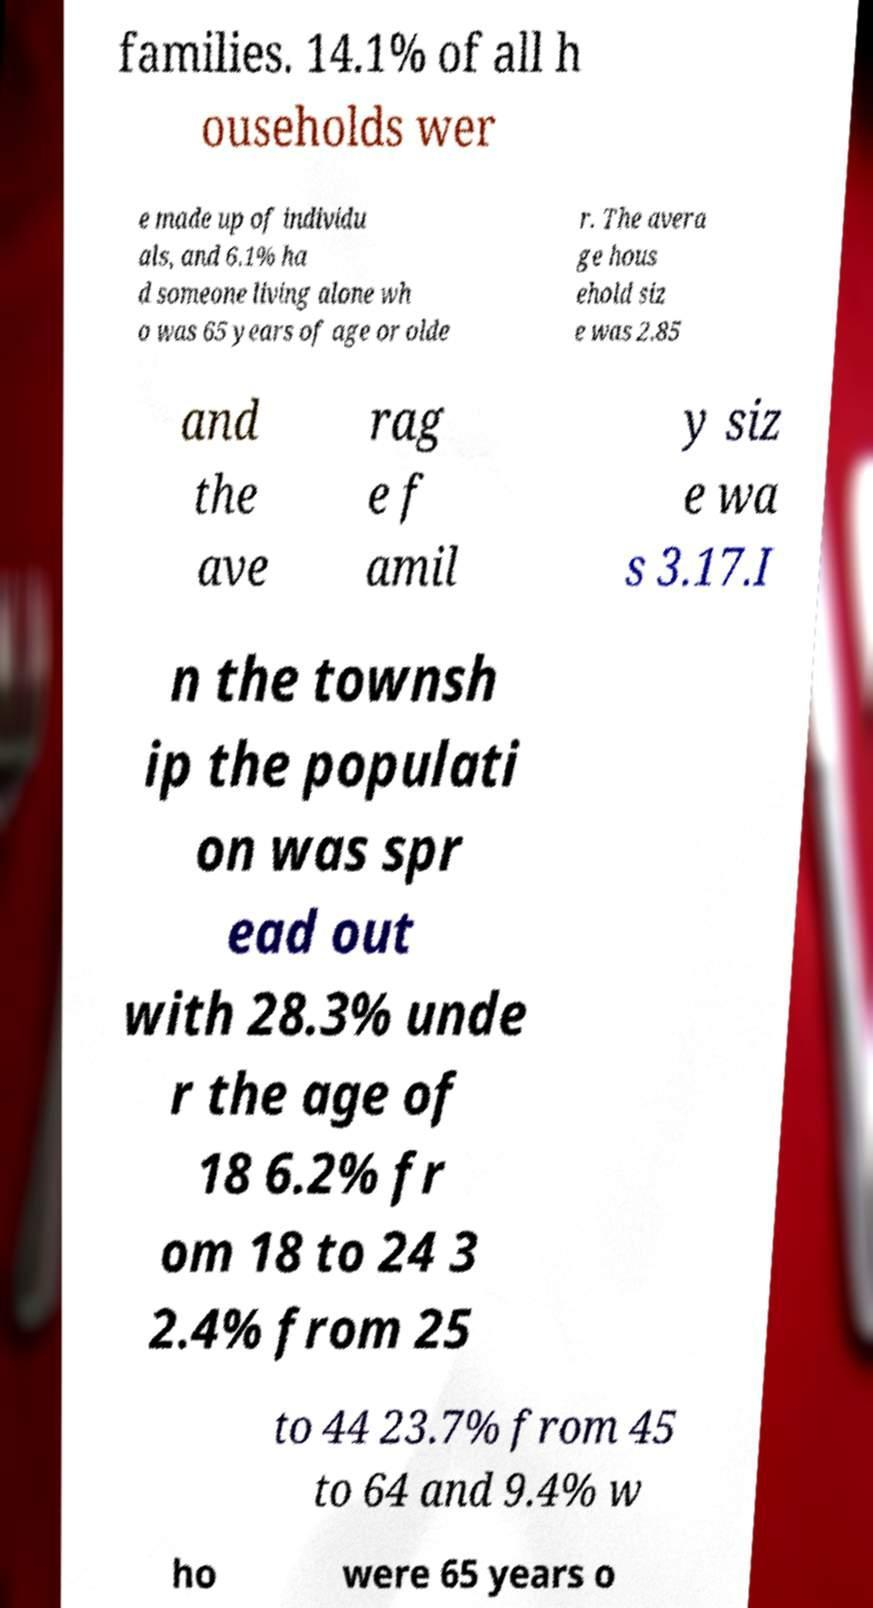Could you extract and type out the text from this image? families. 14.1% of all h ouseholds wer e made up of individu als, and 6.1% ha d someone living alone wh o was 65 years of age or olde r. The avera ge hous ehold siz e was 2.85 and the ave rag e f amil y siz e wa s 3.17.I n the townsh ip the populati on was spr ead out with 28.3% unde r the age of 18 6.2% fr om 18 to 24 3 2.4% from 25 to 44 23.7% from 45 to 64 and 9.4% w ho were 65 years o 